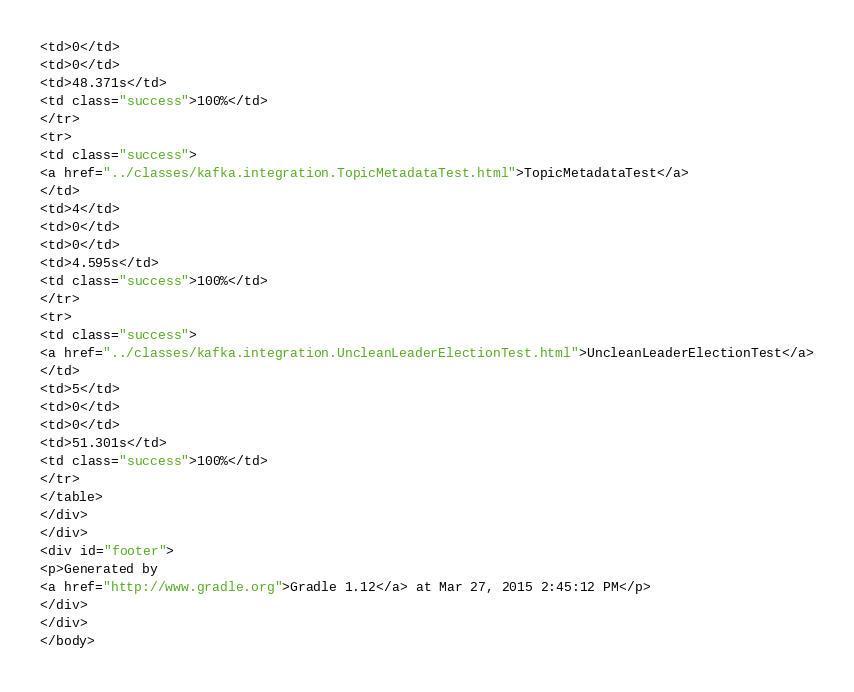Convert code to text. <code><loc_0><loc_0><loc_500><loc_500><_HTML_><td>0</td>
<td>0</td>
<td>48.371s</td>
<td class="success">100%</td>
</tr>
<tr>
<td class="success">
<a href="../classes/kafka.integration.TopicMetadataTest.html">TopicMetadataTest</a>
</td>
<td>4</td>
<td>0</td>
<td>0</td>
<td>4.595s</td>
<td class="success">100%</td>
</tr>
<tr>
<td class="success">
<a href="../classes/kafka.integration.UncleanLeaderElectionTest.html">UncleanLeaderElectionTest</a>
</td>
<td>5</td>
<td>0</td>
<td>0</td>
<td>51.301s</td>
<td class="success">100%</td>
</tr>
</table>
</div>
</div>
<div id="footer">
<p>Generated by 
<a href="http://www.gradle.org">Gradle 1.12</a> at Mar 27, 2015 2:45:12 PM</p>
</div>
</div>
</body></code> 